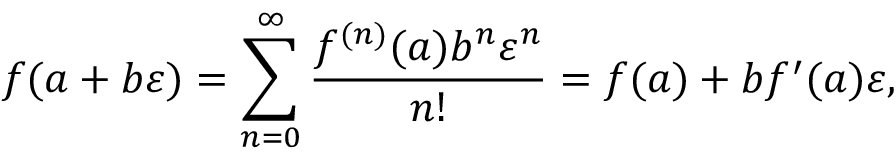Convert formula to latex. <formula><loc_0><loc_0><loc_500><loc_500>f ( a + b \varepsilon ) = \sum _ { n = 0 } ^ { \infty } { \frac { f ^ { ( n ) } ( a ) b ^ { n } \varepsilon ^ { n } } { n ! } } = f ( a ) + b f ^ { \prime } ( a ) \varepsilon ,</formula> 